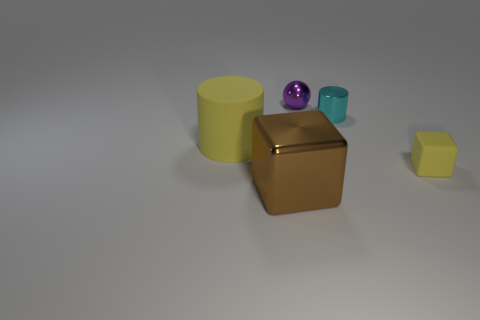How many things are large brown objects or yellow objects left of the cyan cylinder?
Your response must be concise. 2. There is a large yellow object that is the same shape as the cyan object; what material is it?
Keep it short and to the point. Rubber. Is there anything else that is the same material as the brown block?
Offer a terse response. Yes. What is the small object that is behind the small yellow block and in front of the small purple metal thing made of?
Your response must be concise. Metal. How many cyan things have the same shape as the big brown shiny thing?
Ensure brevity in your answer.  0. What is the color of the cylinder to the right of the rubber object on the left side of the large brown cube?
Keep it short and to the point. Cyan. Is the number of blocks that are on the left side of the tiny matte block the same as the number of gray cylinders?
Your answer should be compact. No. Is there a yellow matte thing that has the same size as the rubber block?
Your answer should be compact. No. There is a brown block; is its size the same as the yellow thing that is behind the yellow cube?
Give a very brief answer. Yes. Are there an equal number of tiny yellow cubes to the left of the metal sphere and cyan metallic objects that are in front of the metallic cylinder?
Ensure brevity in your answer.  Yes. 